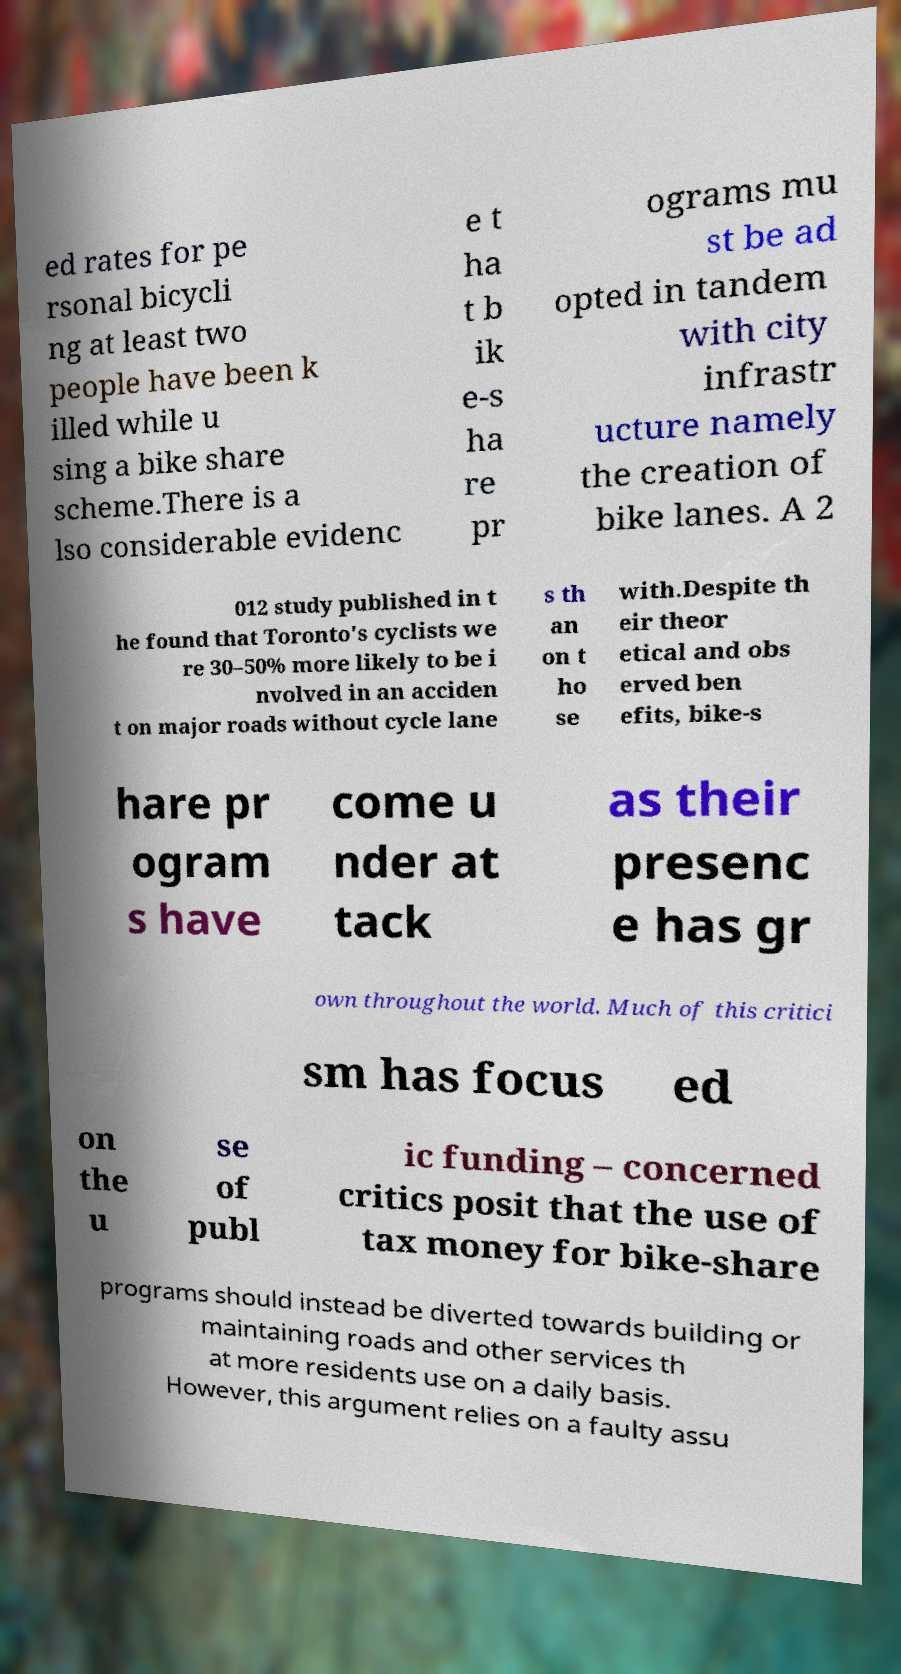Can you accurately transcribe the text from the provided image for me? ed rates for pe rsonal bicycli ng at least two people have been k illed while u sing a bike share scheme.There is a lso considerable evidenc e t ha t b ik e-s ha re pr ograms mu st be ad opted in tandem with city infrastr ucture namely the creation of bike lanes. A 2 012 study published in t he found that Toronto's cyclists we re 30–50% more likely to be i nvolved in an acciden t on major roads without cycle lane s th an on t ho se with.Despite th eir theor etical and obs erved ben efits, bike-s hare pr ogram s have come u nder at tack as their presenc e has gr own throughout the world. Much of this critici sm has focus ed on the u se of publ ic funding – concerned critics posit that the use of tax money for bike-share programs should instead be diverted towards building or maintaining roads and other services th at more residents use on a daily basis. However, this argument relies on a faulty assu 